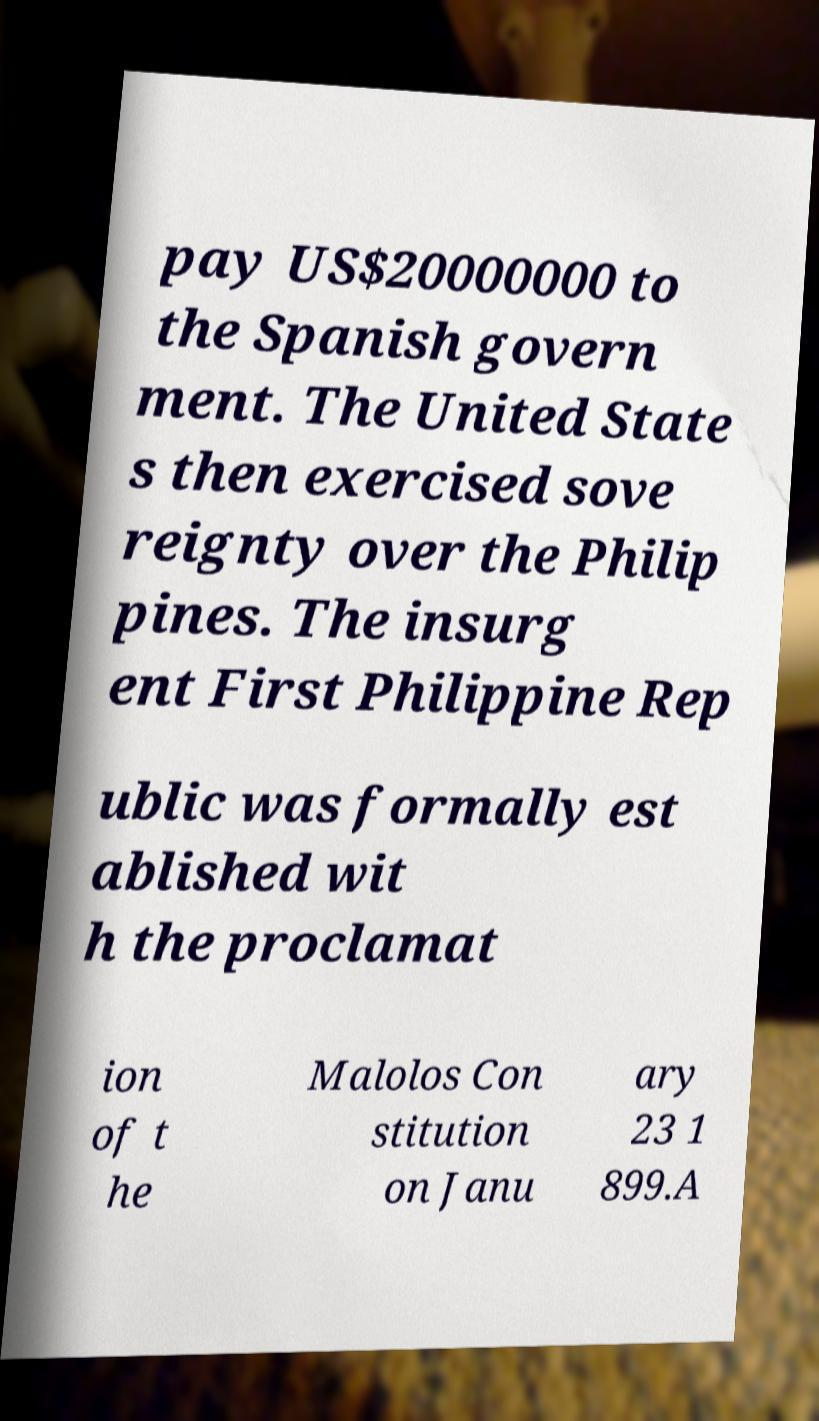Can you read and provide the text displayed in the image?This photo seems to have some interesting text. Can you extract and type it out for me? pay US$20000000 to the Spanish govern ment. The United State s then exercised sove reignty over the Philip pines. The insurg ent First Philippine Rep ublic was formally est ablished wit h the proclamat ion of t he Malolos Con stitution on Janu ary 23 1 899.A 